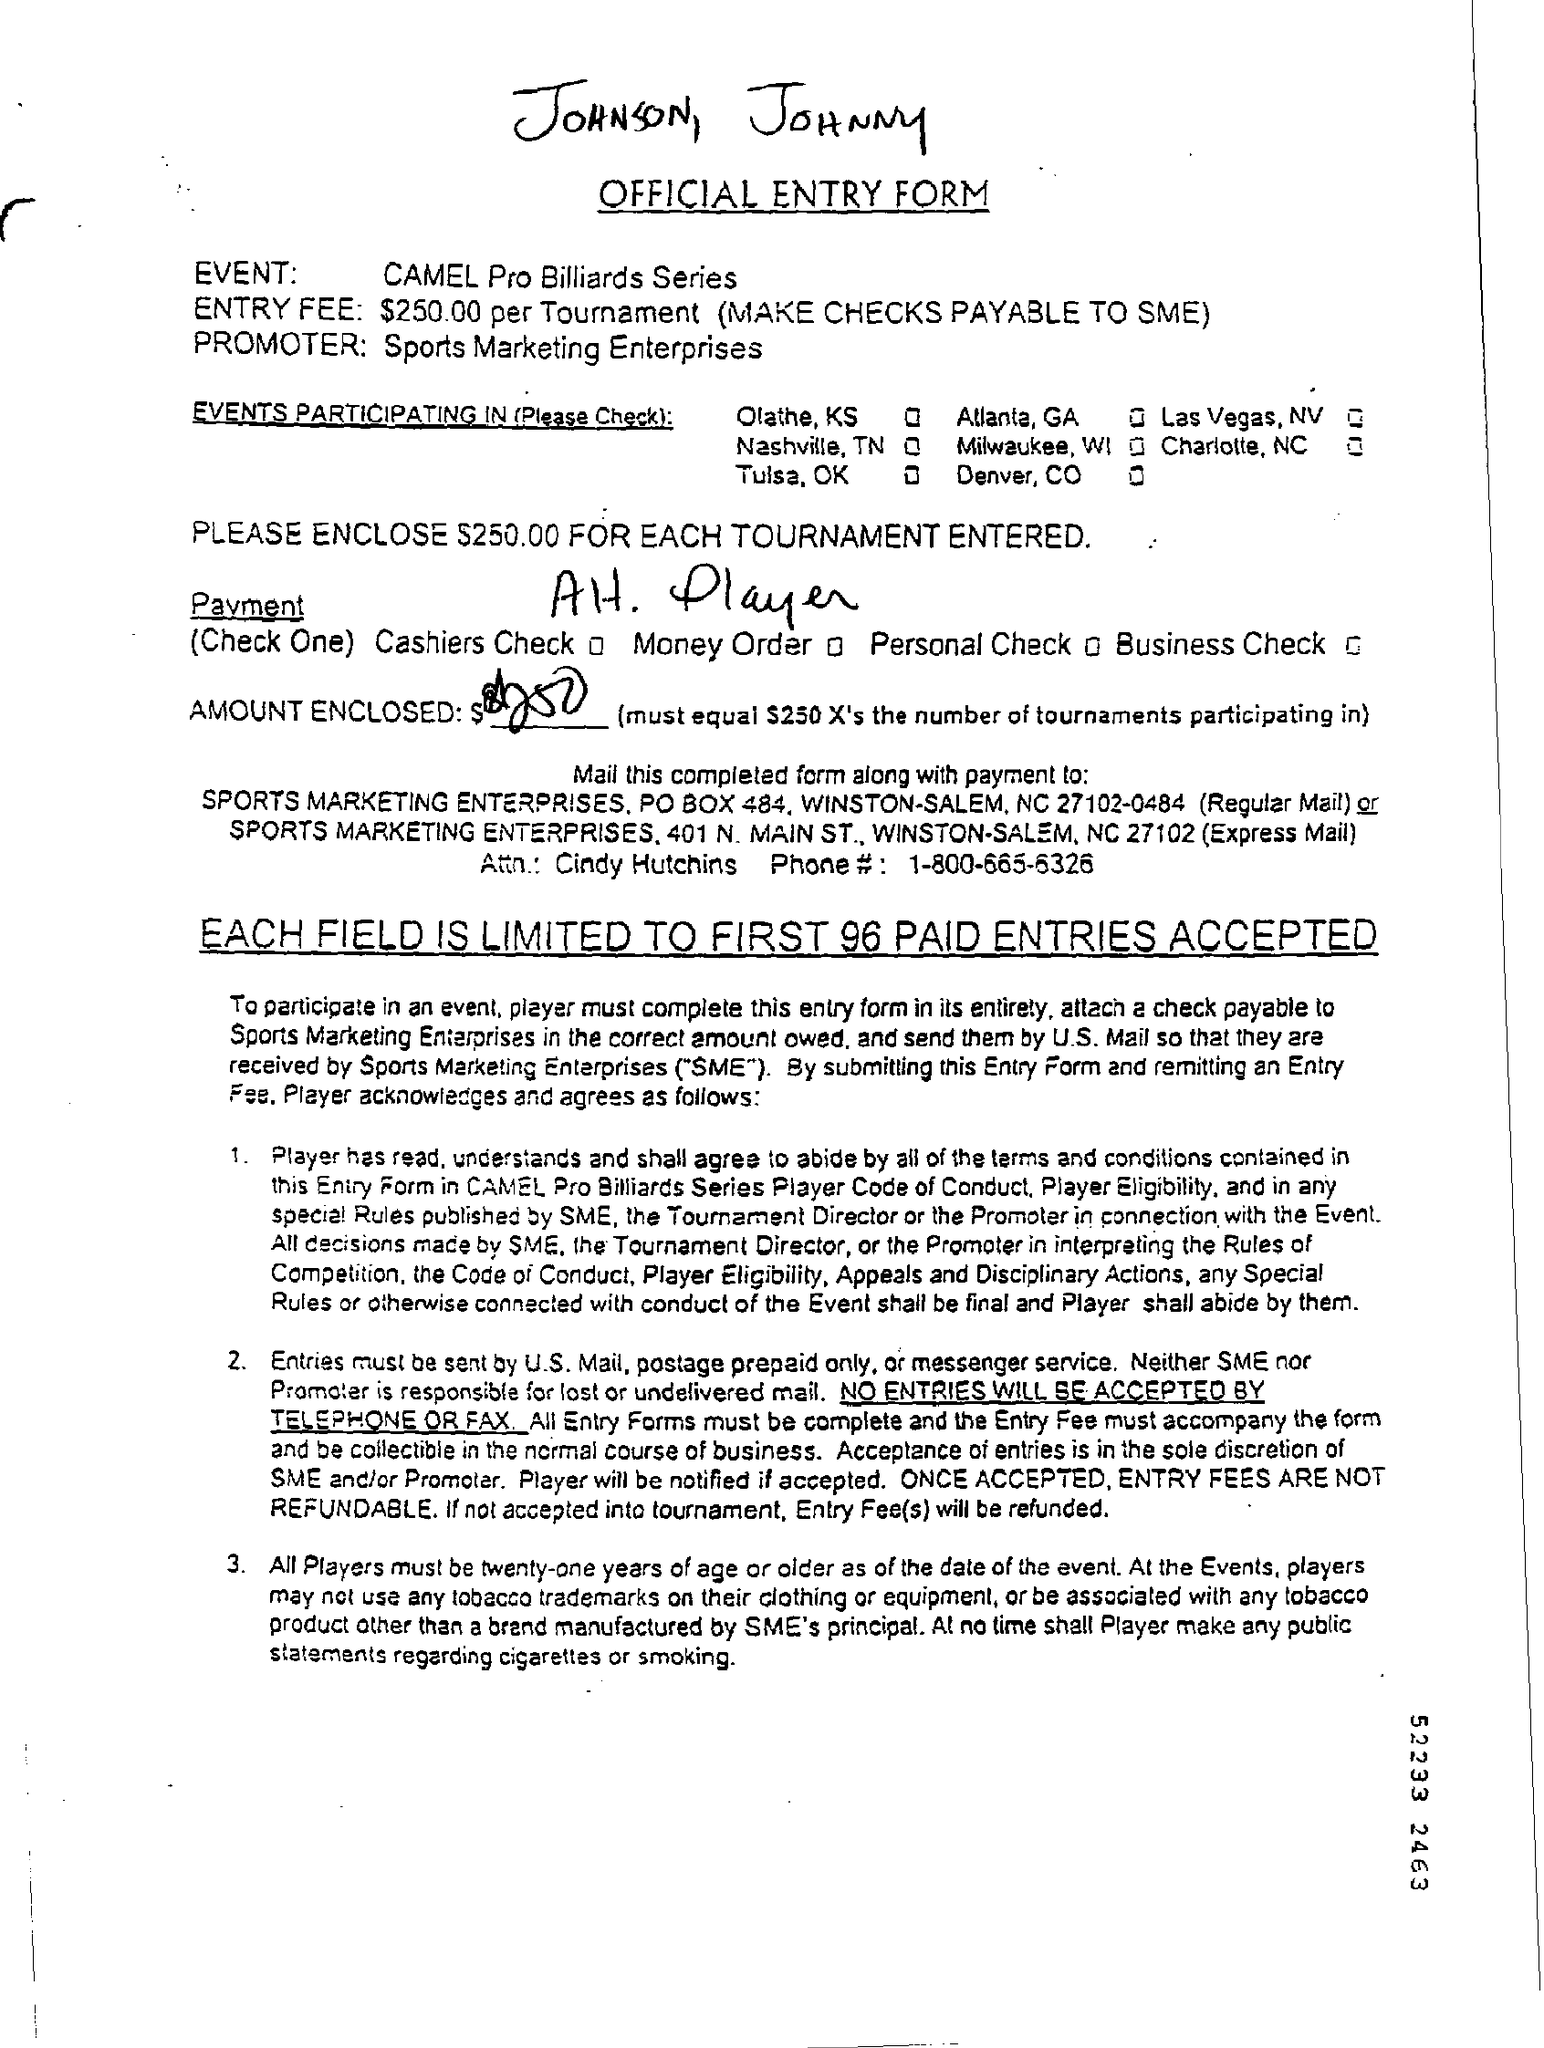What must be the age of the players as of the date of the event ?
Provide a short and direct response. Twenty-one years of age or older. Each field is limited to first how many paid entries accepted ?
Provide a succinct answer. 96. 